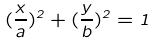<formula> <loc_0><loc_0><loc_500><loc_500>( \frac { x } { a } ) ^ { 2 } + ( \frac { y } { b } ) ^ { 2 } = 1</formula> 